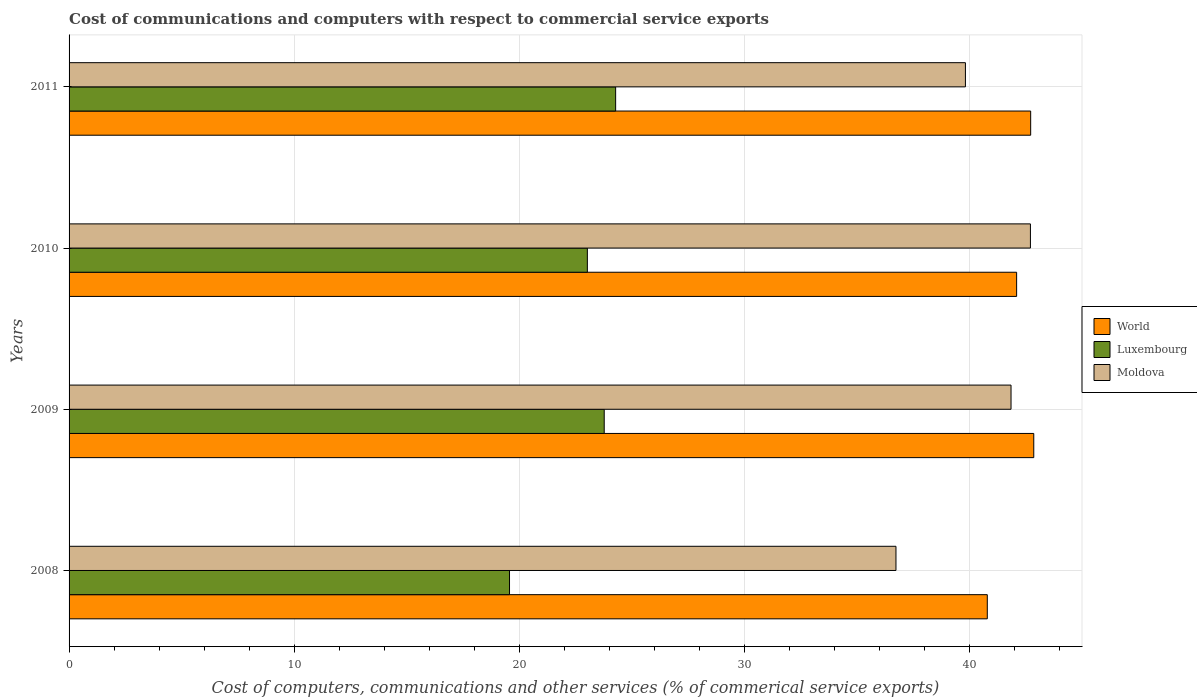Are the number of bars per tick equal to the number of legend labels?
Make the answer very short. Yes. What is the cost of communications and computers in Luxembourg in 2009?
Make the answer very short. 23.77. Across all years, what is the maximum cost of communications and computers in Luxembourg?
Your answer should be compact. 24.28. Across all years, what is the minimum cost of communications and computers in Moldova?
Make the answer very short. 36.73. In which year was the cost of communications and computers in Luxembourg minimum?
Make the answer very short. 2008. What is the total cost of communications and computers in Moldova in the graph?
Ensure brevity in your answer.  161.09. What is the difference between the cost of communications and computers in World in 2009 and that in 2010?
Offer a very short reply. 0.76. What is the difference between the cost of communications and computers in World in 2010 and the cost of communications and computers in Moldova in 2008?
Provide a succinct answer. 5.36. What is the average cost of communications and computers in World per year?
Offer a very short reply. 42.11. In the year 2011, what is the difference between the cost of communications and computers in Moldova and cost of communications and computers in Luxembourg?
Your answer should be compact. 15.54. What is the ratio of the cost of communications and computers in Moldova in 2008 to that in 2010?
Your answer should be compact. 0.86. Is the cost of communications and computers in World in 2009 less than that in 2010?
Your answer should be very brief. No. Is the difference between the cost of communications and computers in Moldova in 2008 and 2011 greater than the difference between the cost of communications and computers in Luxembourg in 2008 and 2011?
Your response must be concise. Yes. What is the difference between the highest and the second highest cost of communications and computers in Luxembourg?
Your response must be concise. 0.51. What is the difference between the highest and the lowest cost of communications and computers in World?
Make the answer very short. 2.06. What does the 1st bar from the top in 2011 represents?
Your answer should be very brief. Moldova. What does the 2nd bar from the bottom in 2010 represents?
Keep it short and to the point. Luxembourg. Are all the bars in the graph horizontal?
Your answer should be very brief. Yes. How many years are there in the graph?
Keep it short and to the point. 4. What is the difference between two consecutive major ticks on the X-axis?
Provide a short and direct response. 10. Does the graph contain grids?
Your response must be concise. Yes. How many legend labels are there?
Provide a succinct answer. 3. What is the title of the graph?
Your answer should be compact. Cost of communications and computers with respect to commercial service exports. Does "Bermuda" appear as one of the legend labels in the graph?
Your answer should be compact. No. What is the label or title of the X-axis?
Provide a succinct answer. Cost of computers, communications and other services (% of commerical service exports). What is the Cost of computers, communications and other services (% of commerical service exports) of World in 2008?
Give a very brief answer. 40.79. What is the Cost of computers, communications and other services (% of commerical service exports) in Luxembourg in 2008?
Ensure brevity in your answer.  19.56. What is the Cost of computers, communications and other services (% of commerical service exports) of Moldova in 2008?
Provide a short and direct response. 36.73. What is the Cost of computers, communications and other services (% of commerical service exports) of World in 2009?
Provide a succinct answer. 42.85. What is the Cost of computers, communications and other services (% of commerical service exports) of Luxembourg in 2009?
Your answer should be very brief. 23.77. What is the Cost of computers, communications and other services (% of commerical service exports) of Moldova in 2009?
Give a very brief answer. 41.84. What is the Cost of computers, communications and other services (% of commerical service exports) of World in 2010?
Your answer should be very brief. 42.09. What is the Cost of computers, communications and other services (% of commerical service exports) of Luxembourg in 2010?
Offer a very short reply. 23.02. What is the Cost of computers, communications and other services (% of commerical service exports) in Moldova in 2010?
Give a very brief answer. 42.7. What is the Cost of computers, communications and other services (% of commerical service exports) in World in 2011?
Provide a succinct answer. 42.71. What is the Cost of computers, communications and other services (% of commerical service exports) in Luxembourg in 2011?
Your response must be concise. 24.28. What is the Cost of computers, communications and other services (% of commerical service exports) of Moldova in 2011?
Give a very brief answer. 39.82. Across all years, what is the maximum Cost of computers, communications and other services (% of commerical service exports) of World?
Your answer should be compact. 42.85. Across all years, what is the maximum Cost of computers, communications and other services (% of commerical service exports) of Luxembourg?
Offer a terse response. 24.28. Across all years, what is the maximum Cost of computers, communications and other services (% of commerical service exports) of Moldova?
Provide a short and direct response. 42.7. Across all years, what is the minimum Cost of computers, communications and other services (% of commerical service exports) of World?
Keep it short and to the point. 40.79. Across all years, what is the minimum Cost of computers, communications and other services (% of commerical service exports) of Luxembourg?
Offer a very short reply. 19.56. Across all years, what is the minimum Cost of computers, communications and other services (% of commerical service exports) of Moldova?
Provide a succinct answer. 36.73. What is the total Cost of computers, communications and other services (% of commerical service exports) in World in the graph?
Make the answer very short. 168.44. What is the total Cost of computers, communications and other services (% of commerical service exports) of Luxembourg in the graph?
Offer a very short reply. 90.64. What is the total Cost of computers, communications and other services (% of commerical service exports) of Moldova in the graph?
Your response must be concise. 161.09. What is the difference between the Cost of computers, communications and other services (% of commerical service exports) of World in 2008 and that in 2009?
Provide a succinct answer. -2.06. What is the difference between the Cost of computers, communications and other services (% of commerical service exports) in Luxembourg in 2008 and that in 2009?
Make the answer very short. -4.21. What is the difference between the Cost of computers, communications and other services (% of commerical service exports) of Moldova in 2008 and that in 2009?
Offer a terse response. -5.11. What is the difference between the Cost of computers, communications and other services (% of commerical service exports) in World in 2008 and that in 2010?
Provide a succinct answer. -1.3. What is the difference between the Cost of computers, communications and other services (% of commerical service exports) of Luxembourg in 2008 and that in 2010?
Give a very brief answer. -3.46. What is the difference between the Cost of computers, communications and other services (% of commerical service exports) of Moldova in 2008 and that in 2010?
Offer a terse response. -5.97. What is the difference between the Cost of computers, communications and other services (% of commerical service exports) in World in 2008 and that in 2011?
Offer a terse response. -1.93. What is the difference between the Cost of computers, communications and other services (% of commerical service exports) of Luxembourg in 2008 and that in 2011?
Provide a short and direct response. -4.71. What is the difference between the Cost of computers, communications and other services (% of commerical service exports) of Moldova in 2008 and that in 2011?
Keep it short and to the point. -3.09. What is the difference between the Cost of computers, communications and other services (% of commerical service exports) of World in 2009 and that in 2010?
Offer a terse response. 0.76. What is the difference between the Cost of computers, communications and other services (% of commerical service exports) in Luxembourg in 2009 and that in 2010?
Give a very brief answer. 0.75. What is the difference between the Cost of computers, communications and other services (% of commerical service exports) in Moldova in 2009 and that in 2010?
Provide a short and direct response. -0.86. What is the difference between the Cost of computers, communications and other services (% of commerical service exports) in World in 2009 and that in 2011?
Keep it short and to the point. 0.14. What is the difference between the Cost of computers, communications and other services (% of commerical service exports) in Luxembourg in 2009 and that in 2011?
Provide a short and direct response. -0.51. What is the difference between the Cost of computers, communications and other services (% of commerical service exports) of Moldova in 2009 and that in 2011?
Ensure brevity in your answer.  2.03. What is the difference between the Cost of computers, communications and other services (% of commerical service exports) in World in 2010 and that in 2011?
Your answer should be very brief. -0.62. What is the difference between the Cost of computers, communications and other services (% of commerical service exports) of Luxembourg in 2010 and that in 2011?
Ensure brevity in your answer.  -1.26. What is the difference between the Cost of computers, communications and other services (% of commerical service exports) in Moldova in 2010 and that in 2011?
Provide a succinct answer. 2.89. What is the difference between the Cost of computers, communications and other services (% of commerical service exports) in World in 2008 and the Cost of computers, communications and other services (% of commerical service exports) in Luxembourg in 2009?
Keep it short and to the point. 17.02. What is the difference between the Cost of computers, communications and other services (% of commerical service exports) in World in 2008 and the Cost of computers, communications and other services (% of commerical service exports) in Moldova in 2009?
Your response must be concise. -1.05. What is the difference between the Cost of computers, communications and other services (% of commerical service exports) of Luxembourg in 2008 and the Cost of computers, communications and other services (% of commerical service exports) of Moldova in 2009?
Your answer should be compact. -22.28. What is the difference between the Cost of computers, communications and other services (% of commerical service exports) of World in 2008 and the Cost of computers, communications and other services (% of commerical service exports) of Luxembourg in 2010?
Ensure brevity in your answer.  17.76. What is the difference between the Cost of computers, communications and other services (% of commerical service exports) of World in 2008 and the Cost of computers, communications and other services (% of commerical service exports) of Moldova in 2010?
Provide a short and direct response. -1.92. What is the difference between the Cost of computers, communications and other services (% of commerical service exports) in Luxembourg in 2008 and the Cost of computers, communications and other services (% of commerical service exports) in Moldova in 2010?
Ensure brevity in your answer.  -23.14. What is the difference between the Cost of computers, communications and other services (% of commerical service exports) of World in 2008 and the Cost of computers, communications and other services (% of commerical service exports) of Luxembourg in 2011?
Offer a very short reply. 16.51. What is the difference between the Cost of computers, communications and other services (% of commerical service exports) of World in 2008 and the Cost of computers, communications and other services (% of commerical service exports) of Moldova in 2011?
Your response must be concise. 0.97. What is the difference between the Cost of computers, communications and other services (% of commerical service exports) in Luxembourg in 2008 and the Cost of computers, communications and other services (% of commerical service exports) in Moldova in 2011?
Provide a short and direct response. -20.25. What is the difference between the Cost of computers, communications and other services (% of commerical service exports) of World in 2009 and the Cost of computers, communications and other services (% of commerical service exports) of Luxembourg in 2010?
Offer a very short reply. 19.83. What is the difference between the Cost of computers, communications and other services (% of commerical service exports) of World in 2009 and the Cost of computers, communications and other services (% of commerical service exports) of Moldova in 2010?
Provide a short and direct response. 0.15. What is the difference between the Cost of computers, communications and other services (% of commerical service exports) of Luxembourg in 2009 and the Cost of computers, communications and other services (% of commerical service exports) of Moldova in 2010?
Your answer should be very brief. -18.93. What is the difference between the Cost of computers, communications and other services (% of commerical service exports) of World in 2009 and the Cost of computers, communications and other services (% of commerical service exports) of Luxembourg in 2011?
Provide a short and direct response. 18.57. What is the difference between the Cost of computers, communications and other services (% of commerical service exports) of World in 2009 and the Cost of computers, communications and other services (% of commerical service exports) of Moldova in 2011?
Make the answer very short. 3.04. What is the difference between the Cost of computers, communications and other services (% of commerical service exports) in Luxembourg in 2009 and the Cost of computers, communications and other services (% of commerical service exports) in Moldova in 2011?
Give a very brief answer. -16.04. What is the difference between the Cost of computers, communications and other services (% of commerical service exports) of World in 2010 and the Cost of computers, communications and other services (% of commerical service exports) of Luxembourg in 2011?
Give a very brief answer. 17.81. What is the difference between the Cost of computers, communications and other services (% of commerical service exports) in World in 2010 and the Cost of computers, communications and other services (% of commerical service exports) in Moldova in 2011?
Provide a short and direct response. 2.27. What is the difference between the Cost of computers, communications and other services (% of commerical service exports) of Luxembourg in 2010 and the Cost of computers, communications and other services (% of commerical service exports) of Moldova in 2011?
Offer a terse response. -16.79. What is the average Cost of computers, communications and other services (% of commerical service exports) in World per year?
Make the answer very short. 42.11. What is the average Cost of computers, communications and other services (% of commerical service exports) of Luxembourg per year?
Provide a short and direct response. 22.66. What is the average Cost of computers, communications and other services (% of commerical service exports) of Moldova per year?
Give a very brief answer. 40.27. In the year 2008, what is the difference between the Cost of computers, communications and other services (% of commerical service exports) in World and Cost of computers, communications and other services (% of commerical service exports) in Luxembourg?
Provide a succinct answer. 21.22. In the year 2008, what is the difference between the Cost of computers, communications and other services (% of commerical service exports) in World and Cost of computers, communications and other services (% of commerical service exports) in Moldova?
Keep it short and to the point. 4.06. In the year 2008, what is the difference between the Cost of computers, communications and other services (% of commerical service exports) in Luxembourg and Cost of computers, communications and other services (% of commerical service exports) in Moldova?
Provide a short and direct response. -17.17. In the year 2009, what is the difference between the Cost of computers, communications and other services (% of commerical service exports) in World and Cost of computers, communications and other services (% of commerical service exports) in Luxembourg?
Ensure brevity in your answer.  19.08. In the year 2009, what is the difference between the Cost of computers, communications and other services (% of commerical service exports) in World and Cost of computers, communications and other services (% of commerical service exports) in Moldova?
Give a very brief answer. 1.01. In the year 2009, what is the difference between the Cost of computers, communications and other services (% of commerical service exports) in Luxembourg and Cost of computers, communications and other services (% of commerical service exports) in Moldova?
Keep it short and to the point. -18.07. In the year 2010, what is the difference between the Cost of computers, communications and other services (% of commerical service exports) in World and Cost of computers, communications and other services (% of commerical service exports) in Luxembourg?
Provide a short and direct response. 19.07. In the year 2010, what is the difference between the Cost of computers, communications and other services (% of commerical service exports) in World and Cost of computers, communications and other services (% of commerical service exports) in Moldova?
Provide a short and direct response. -0.61. In the year 2010, what is the difference between the Cost of computers, communications and other services (% of commerical service exports) of Luxembourg and Cost of computers, communications and other services (% of commerical service exports) of Moldova?
Provide a succinct answer. -19.68. In the year 2011, what is the difference between the Cost of computers, communications and other services (% of commerical service exports) in World and Cost of computers, communications and other services (% of commerical service exports) in Luxembourg?
Your answer should be compact. 18.44. In the year 2011, what is the difference between the Cost of computers, communications and other services (% of commerical service exports) in World and Cost of computers, communications and other services (% of commerical service exports) in Moldova?
Offer a terse response. 2.9. In the year 2011, what is the difference between the Cost of computers, communications and other services (% of commerical service exports) in Luxembourg and Cost of computers, communications and other services (% of commerical service exports) in Moldova?
Your response must be concise. -15.54. What is the ratio of the Cost of computers, communications and other services (% of commerical service exports) of World in 2008 to that in 2009?
Your response must be concise. 0.95. What is the ratio of the Cost of computers, communications and other services (% of commerical service exports) of Luxembourg in 2008 to that in 2009?
Provide a short and direct response. 0.82. What is the ratio of the Cost of computers, communications and other services (% of commerical service exports) in Moldova in 2008 to that in 2009?
Keep it short and to the point. 0.88. What is the ratio of the Cost of computers, communications and other services (% of commerical service exports) of Luxembourg in 2008 to that in 2010?
Provide a short and direct response. 0.85. What is the ratio of the Cost of computers, communications and other services (% of commerical service exports) in Moldova in 2008 to that in 2010?
Offer a very short reply. 0.86. What is the ratio of the Cost of computers, communications and other services (% of commerical service exports) in World in 2008 to that in 2011?
Your answer should be very brief. 0.95. What is the ratio of the Cost of computers, communications and other services (% of commerical service exports) in Luxembourg in 2008 to that in 2011?
Provide a short and direct response. 0.81. What is the ratio of the Cost of computers, communications and other services (% of commerical service exports) of Moldova in 2008 to that in 2011?
Your response must be concise. 0.92. What is the ratio of the Cost of computers, communications and other services (% of commerical service exports) of World in 2009 to that in 2010?
Your answer should be very brief. 1.02. What is the ratio of the Cost of computers, communications and other services (% of commerical service exports) of Luxembourg in 2009 to that in 2010?
Give a very brief answer. 1.03. What is the ratio of the Cost of computers, communications and other services (% of commerical service exports) of Moldova in 2009 to that in 2010?
Your answer should be very brief. 0.98. What is the ratio of the Cost of computers, communications and other services (% of commerical service exports) in World in 2009 to that in 2011?
Make the answer very short. 1. What is the ratio of the Cost of computers, communications and other services (% of commerical service exports) of Luxembourg in 2009 to that in 2011?
Provide a short and direct response. 0.98. What is the ratio of the Cost of computers, communications and other services (% of commerical service exports) in Moldova in 2009 to that in 2011?
Offer a very short reply. 1.05. What is the ratio of the Cost of computers, communications and other services (% of commerical service exports) of World in 2010 to that in 2011?
Keep it short and to the point. 0.99. What is the ratio of the Cost of computers, communications and other services (% of commerical service exports) in Luxembourg in 2010 to that in 2011?
Offer a very short reply. 0.95. What is the ratio of the Cost of computers, communications and other services (% of commerical service exports) of Moldova in 2010 to that in 2011?
Ensure brevity in your answer.  1.07. What is the difference between the highest and the second highest Cost of computers, communications and other services (% of commerical service exports) of World?
Offer a very short reply. 0.14. What is the difference between the highest and the second highest Cost of computers, communications and other services (% of commerical service exports) of Luxembourg?
Make the answer very short. 0.51. What is the difference between the highest and the second highest Cost of computers, communications and other services (% of commerical service exports) in Moldova?
Provide a succinct answer. 0.86. What is the difference between the highest and the lowest Cost of computers, communications and other services (% of commerical service exports) of World?
Offer a very short reply. 2.06. What is the difference between the highest and the lowest Cost of computers, communications and other services (% of commerical service exports) of Luxembourg?
Your response must be concise. 4.71. What is the difference between the highest and the lowest Cost of computers, communications and other services (% of commerical service exports) of Moldova?
Your answer should be compact. 5.97. 